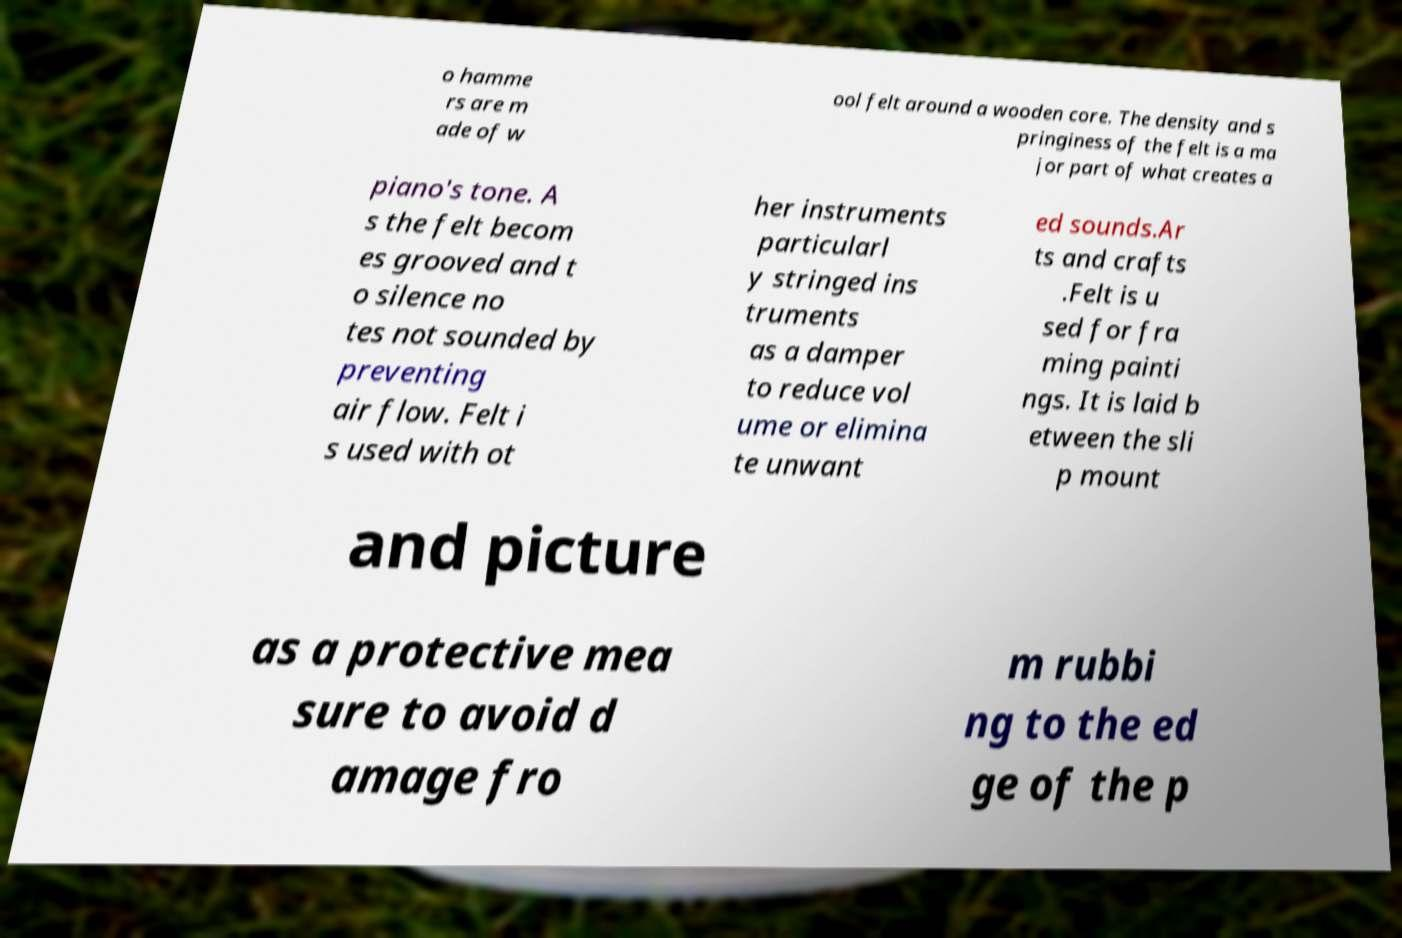What messages or text are displayed in this image? I need them in a readable, typed format. o hamme rs are m ade of w ool felt around a wooden core. The density and s pringiness of the felt is a ma jor part of what creates a piano's tone. A s the felt becom es grooved and t o silence no tes not sounded by preventing air flow. Felt i s used with ot her instruments particularl y stringed ins truments as a damper to reduce vol ume or elimina te unwant ed sounds.Ar ts and crafts .Felt is u sed for fra ming painti ngs. It is laid b etween the sli p mount and picture as a protective mea sure to avoid d amage fro m rubbi ng to the ed ge of the p 